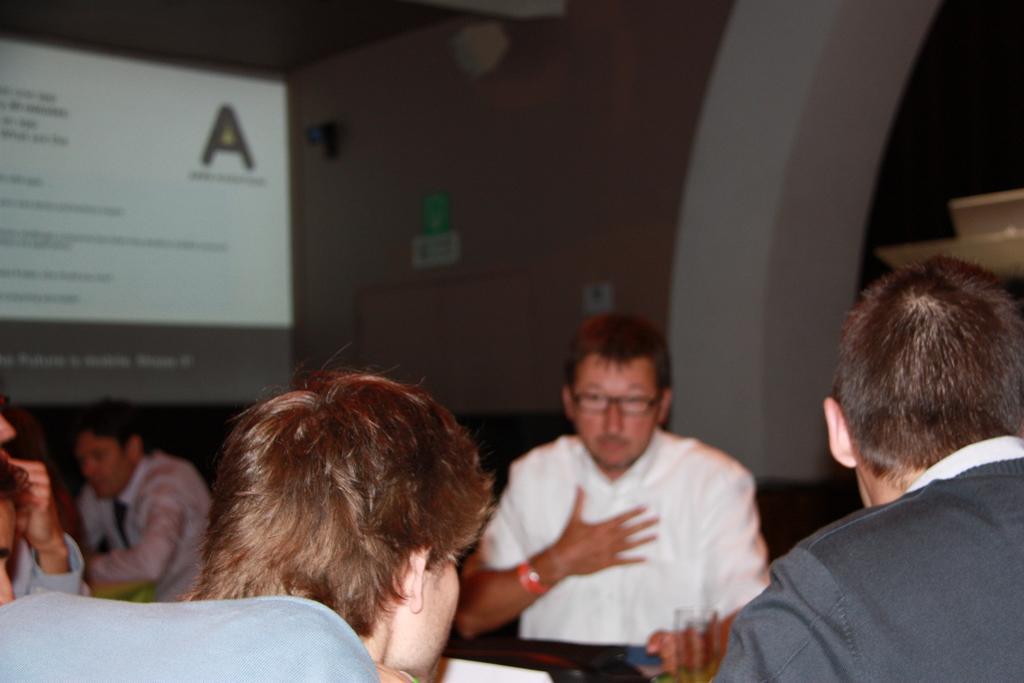How would you summarize this image in a sentence or two? This is the picture of a room. In this image there are group of people sitting. There is a glass and paper on the table. At the back there is a screen. There is a camera and there is a board on the wall. 